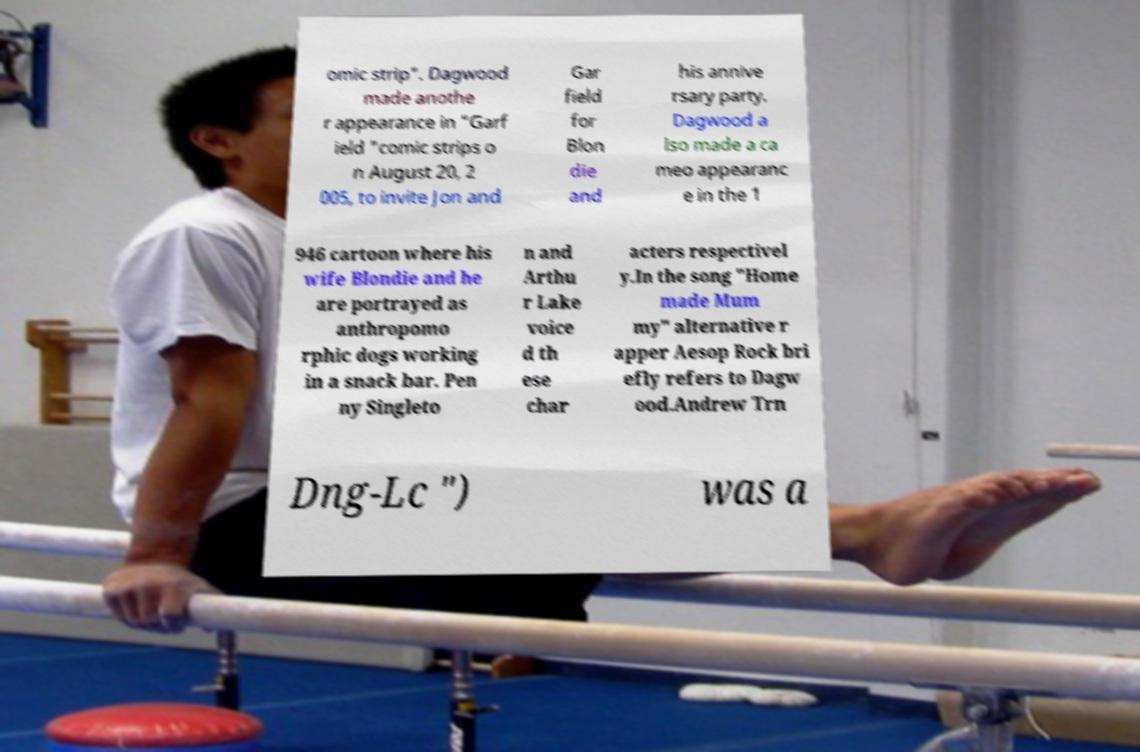Could you assist in decoding the text presented in this image and type it out clearly? omic strip". Dagwood made anothe r appearance in "Garf ield "comic strips o n August 20, 2 005, to invite Jon and Gar field for Blon die and his annive rsary party. Dagwood a lso made a ca meo appearanc e in the 1 946 cartoon where his wife Blondie and he are portrayed as anthropomo rphic dogs working in a snack bar. Pen ny Singleto n and Arthu r Lake voice d th ese char acters respectivel y.In the song "Home made Mum my" alternative r apper Aesop Rock bri efly refers to Dagw ood.Andrew Trn Dng-Lc ") was a 